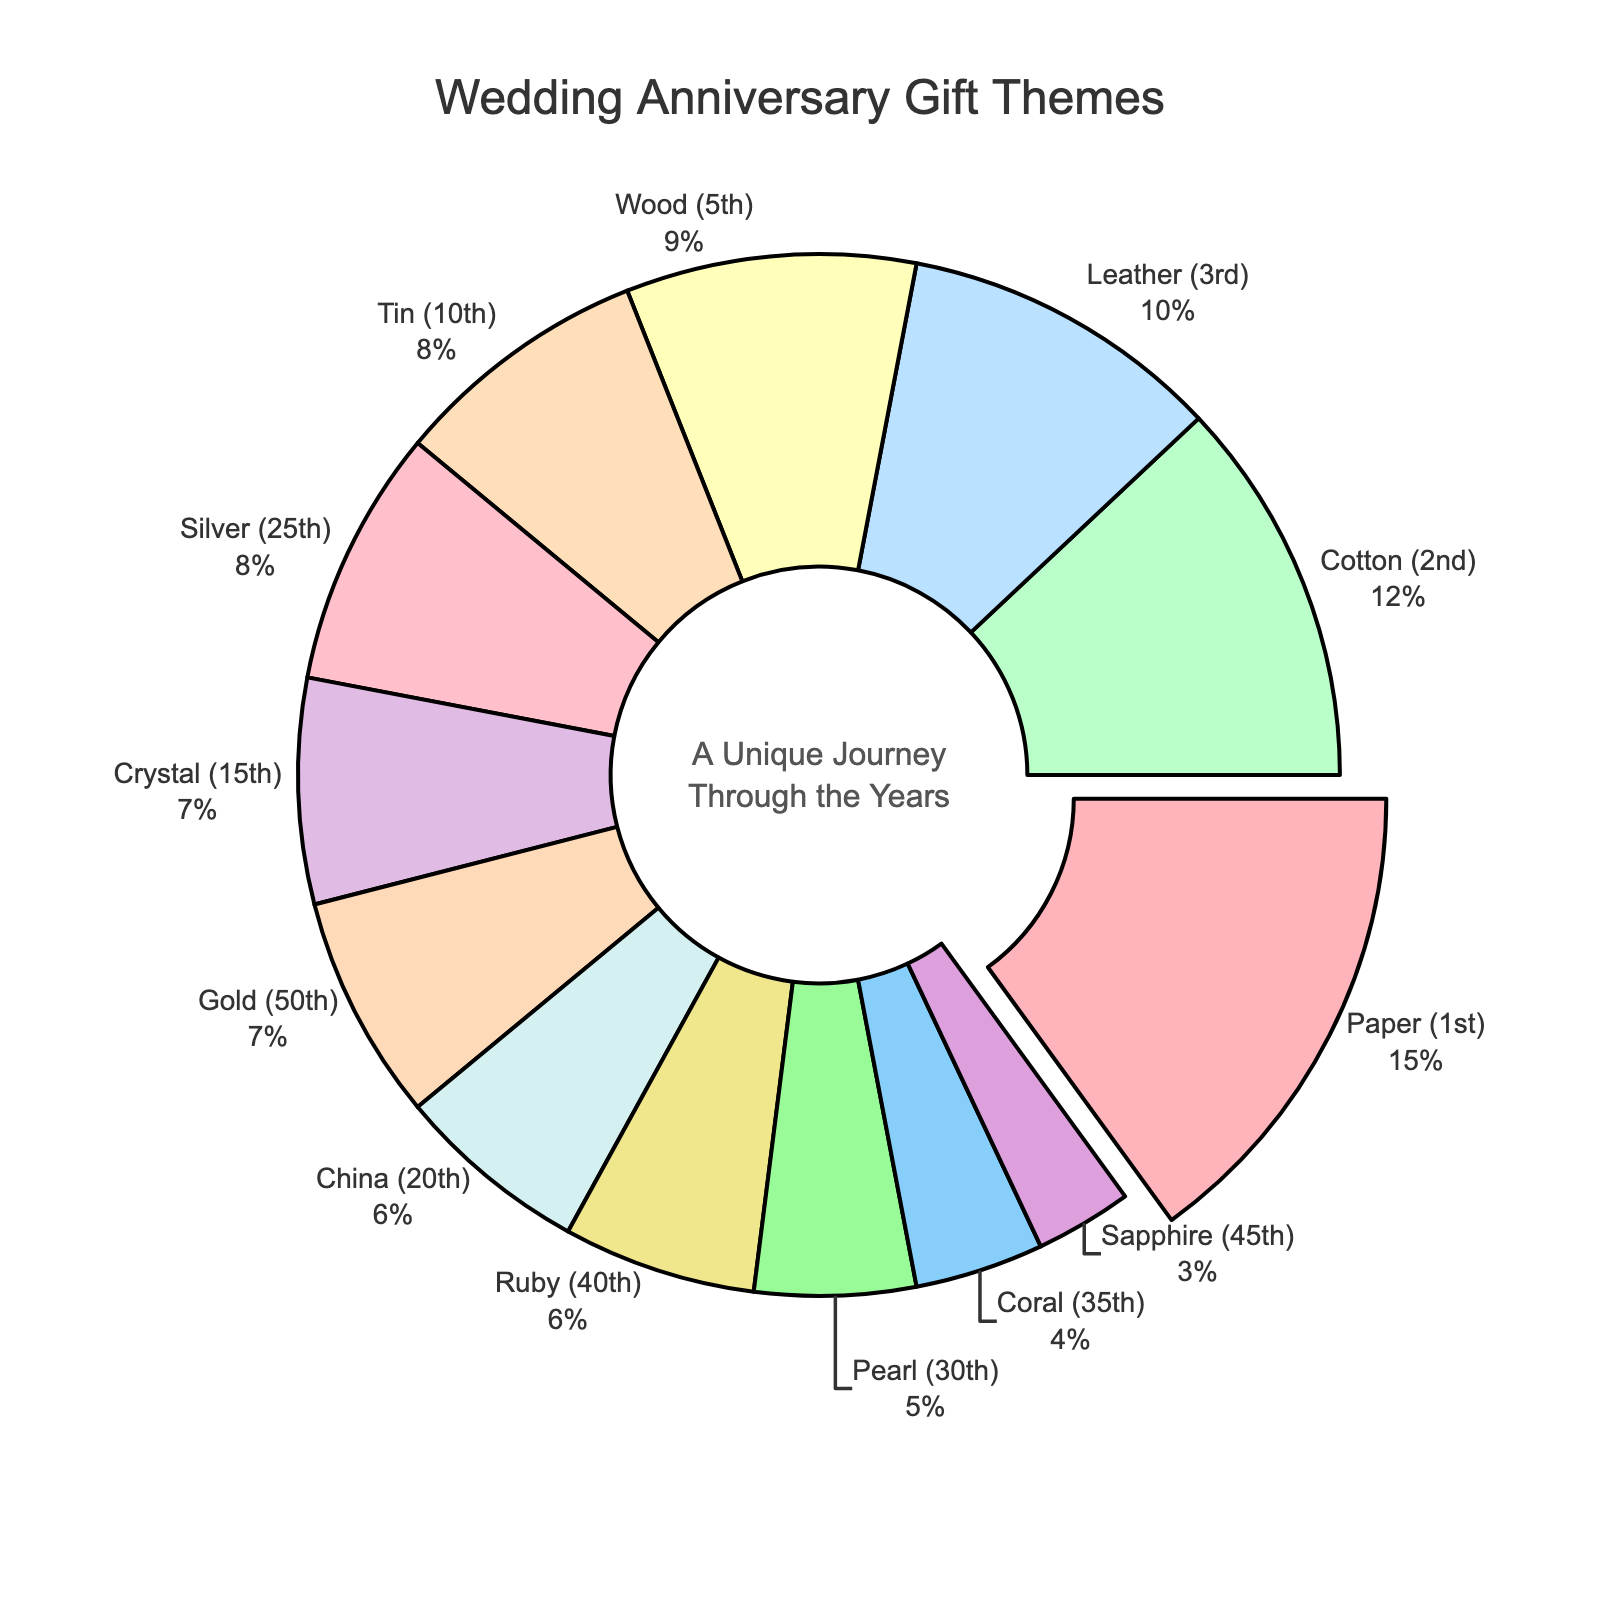What year has the highest percentage for a wedding anniversary gift theme? To determine the year with the highest percentage, look at the labels and percentages on the pie chart. The largest segment should correspond to the highest percentage.
Answer: 1st year (Paper) Which gift theme has the smallest percentage? Identify the smallest segment in the pie chart and check its label to find the gift theme associated with that segment.
Answer: 45th year (Sapphire) What is the sum of percentages for the 25th and 50th years? Locate the segments for the 25th year and the 50th year. The percentages are 8% and 7%, respectively. Sum these percentages: 8 + 7.
Answer: 15% Is the percentage for the Wood theme greater than the percentage for the Leather theme? Compare the segments labeled '5th (Wood)' and '3rd (Leather)'. The Wood theme has a percentage of 9, and the Leather theme has a percentage of 10.
Answer: No Which theme associated with a year divisible by 10 has the higher percentage: Tin or Pearl? Identify segments labeled with years divisible by 10 (10th year for Tin and 30th year for Pearl). Compare their percentages: Tin is 8% and Pearl is 5%.
Answer: Tin Which gift theme segment is pulled out from the chart? The segment that is visually pulled out indicates the theme with the highest percentage. Look for the segment that appears to be separated from the rest.
Answer: Paper What is the difference in percentages between the Ruby and Sapphire themes? Find the percentages of the Ruby (40th year) and Sapphire (45th year) themes: 6% and 3% respectively. Subtract the smaller percentage from the larger one: 6 - 3.
Answer: 3% What combined percentage do the themes for 5th, 15th, and 35th years represent? Locate the segments for the 5th year (Wood - 9%), 15th year (Crystal - 7%), and 35th year (Coral - 4%). Sum these percentages: 9 + 7 + 4.
Answer: 20% Between Crystal and Gold themes, which one ranks higher in terms of percentage and by how much? Compare the percentages of Crystal (15th year) and Gold (50th year): 7% and 7%. Since they are equal, state they rank equally.
Answer: Equal What is the average percentage across all wedding anniversary gift themes? Sum all the percentages provided and divide by the number of themes. The sum is 15 + 12 + 10 + 9 + 8 + 7 + 6 + 8 + 5 + 4 + 6 + 3 + 7 = 100. There are 13 themes, so the average is 100 / 13.
Answer: ~7.69% 